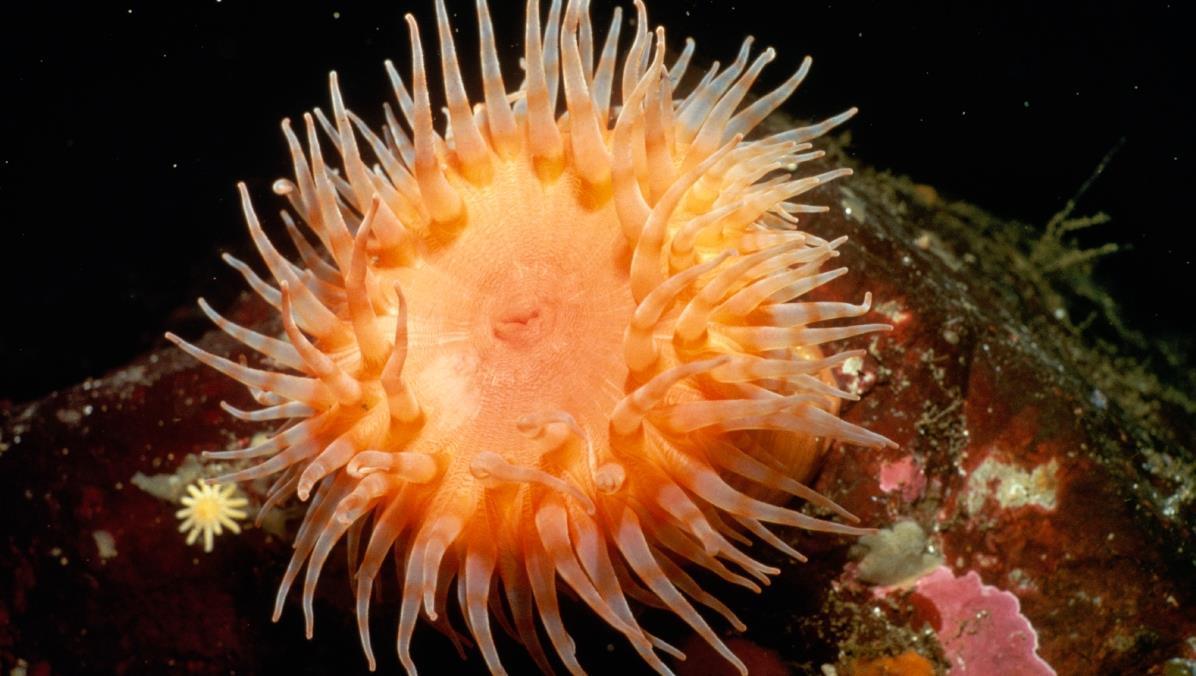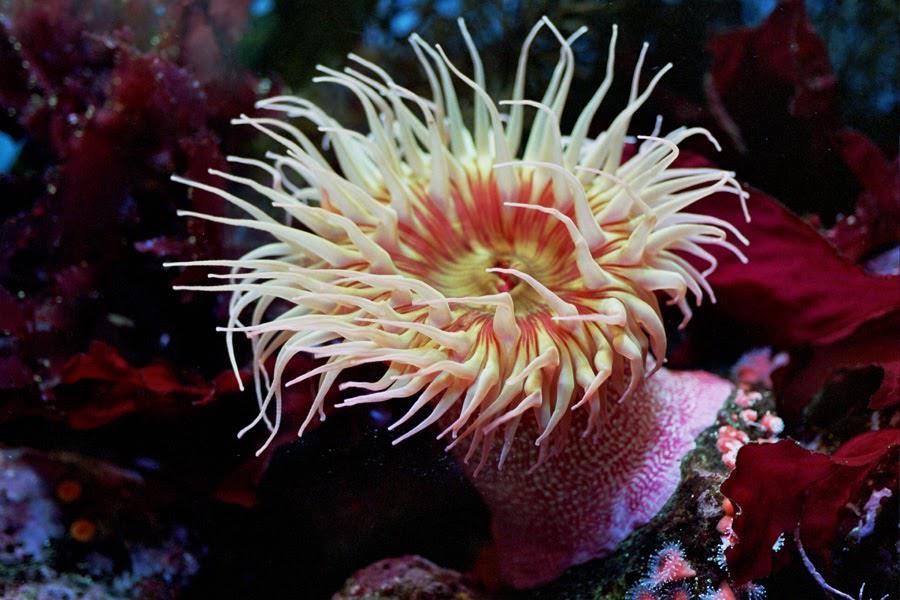The first image is the image on the left, the second image is the image on the right. Considering the images on both sides, is "The left image contains an animal that is not an anemone." valid? Answer yes or no. No. The first image is the image on the left, the second image is the image on the right. Analyze the images presented: Is the assertion "At least one anemone image looks like spaghetti noodles rather than a flower shape." valid? Answer yes or no. No. 